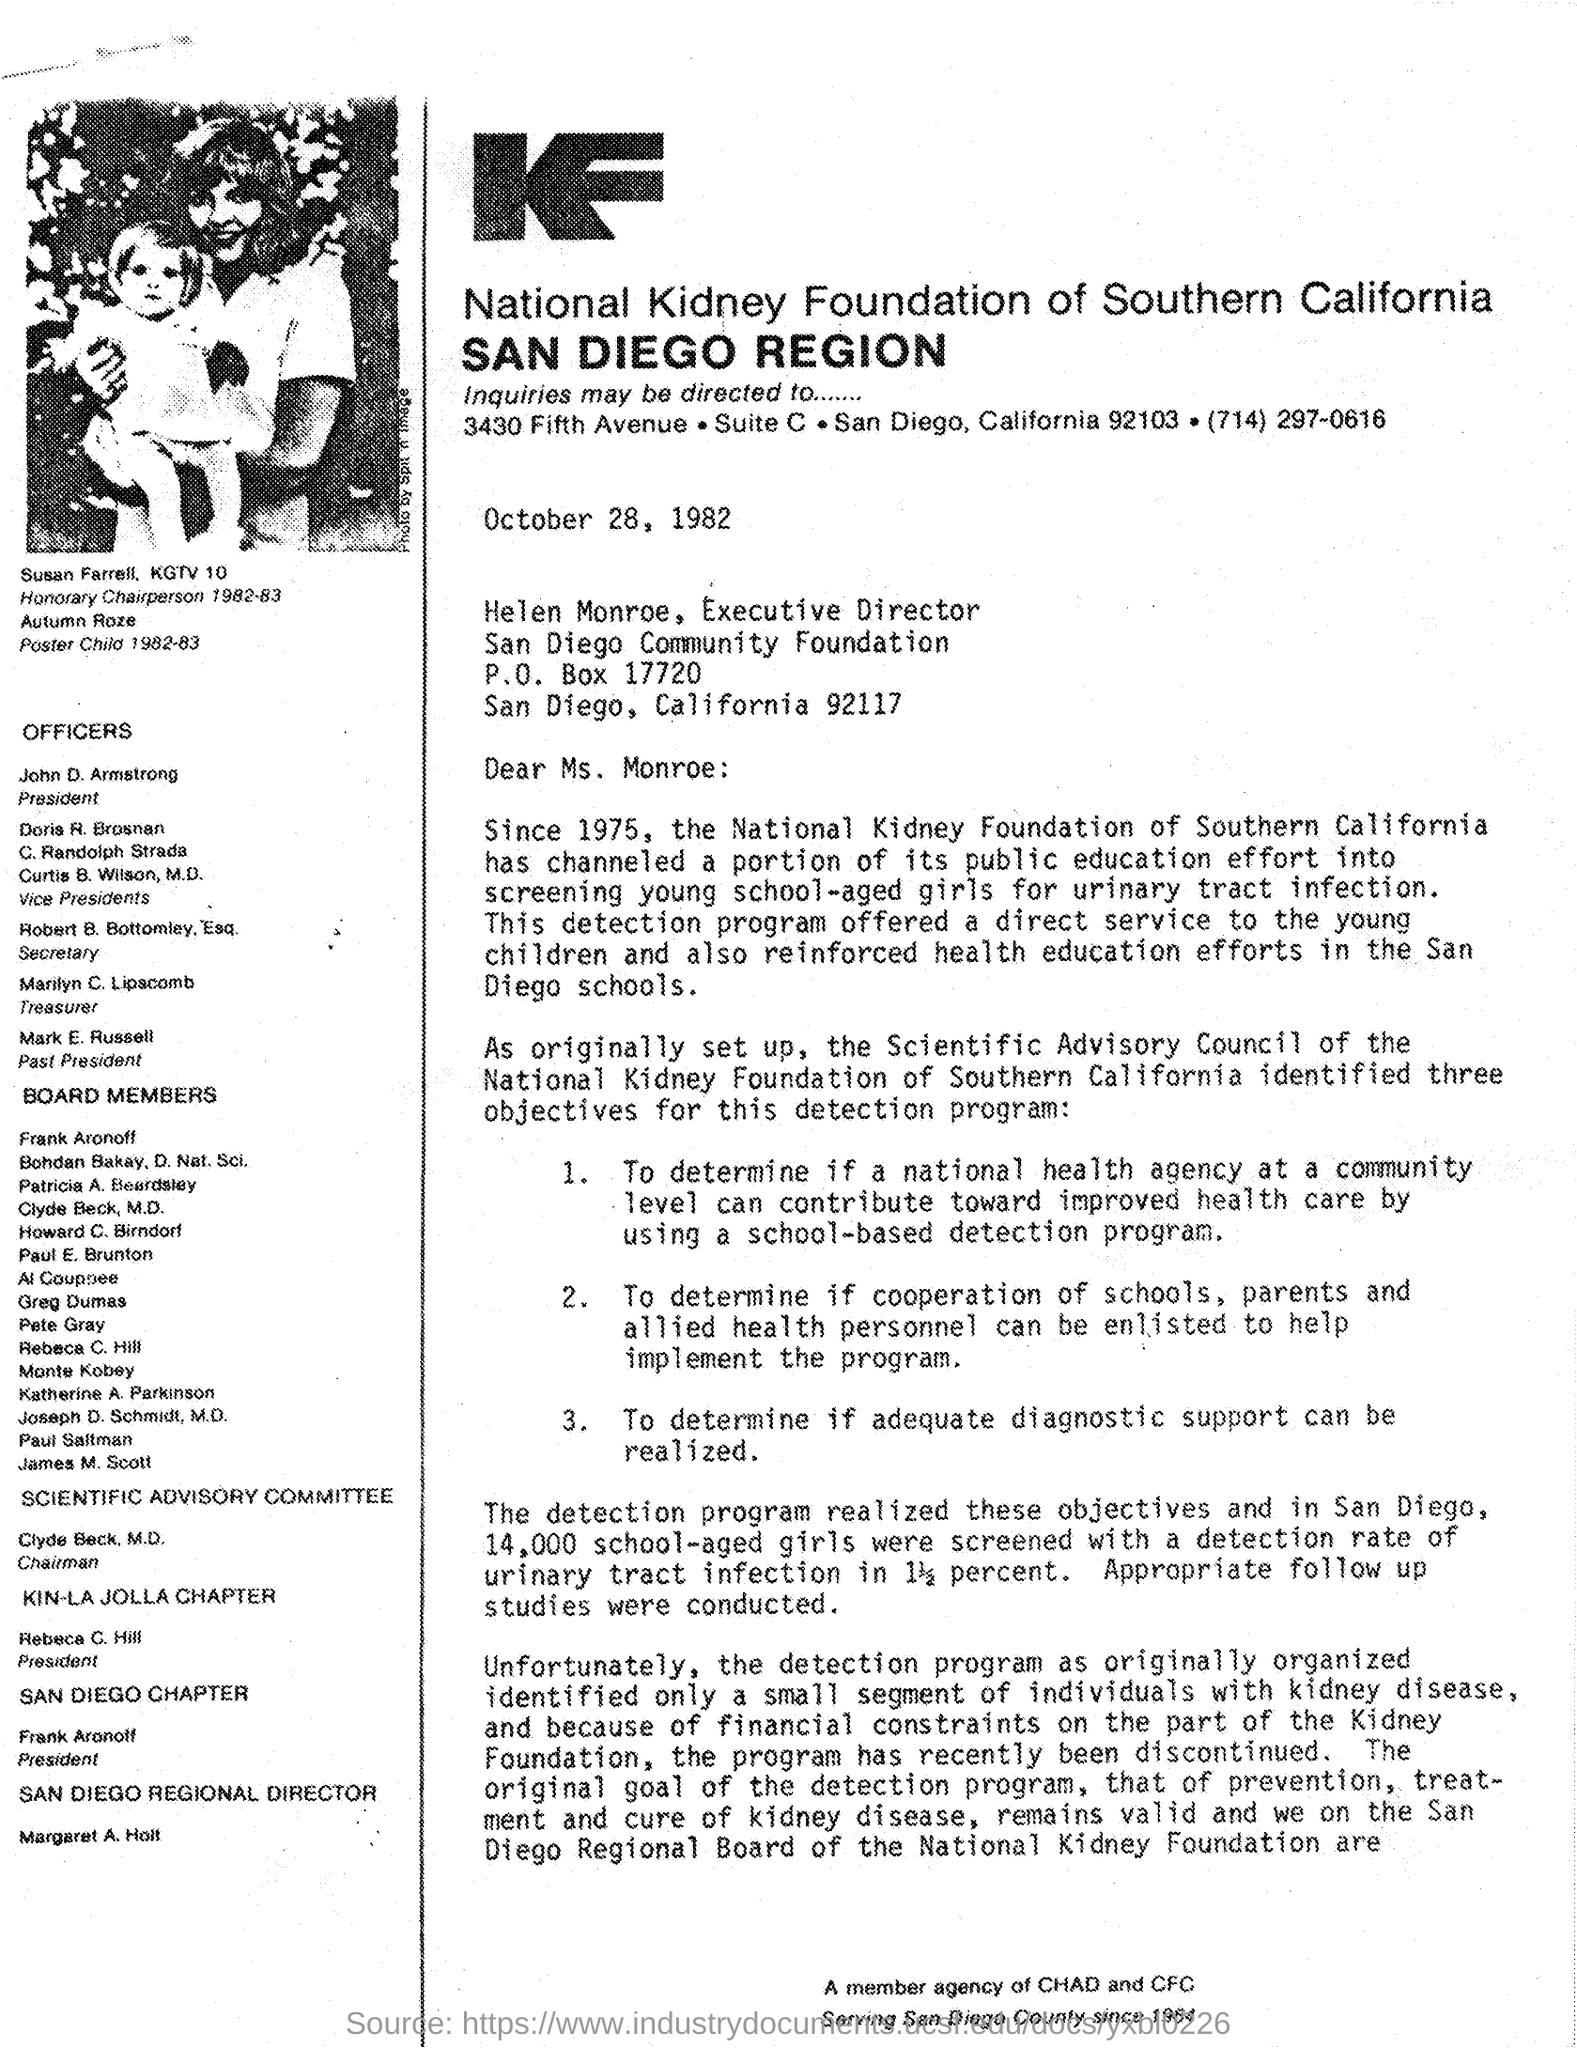To whom,this letter is sent ?
Your response must be concise. Helen Monroe, Executive Director. Who is the 'President' of National kidney Foundation of southern California
Ensure brevity in your answer.  John D. Armstrong. Who is the 'Past President' of National kidney Foundation of southern California ?
Your response must be concise. Mark E. Russell. Who is the 'Chairman' of Scientific advisory committee?
Offer a terse response. Clyde Beck. M.D. Who's picture is shown in the document ?
Offer a terse response. Susan Farrell , KGTV 10. Who is Helen Monroe ?
Ensure brevity in your answer.  Executive Director. Who is the 'Treasurer' of National kidney Foundation of southern California?
Keep it short and to the point. Marilyn C. Lipscomb. 